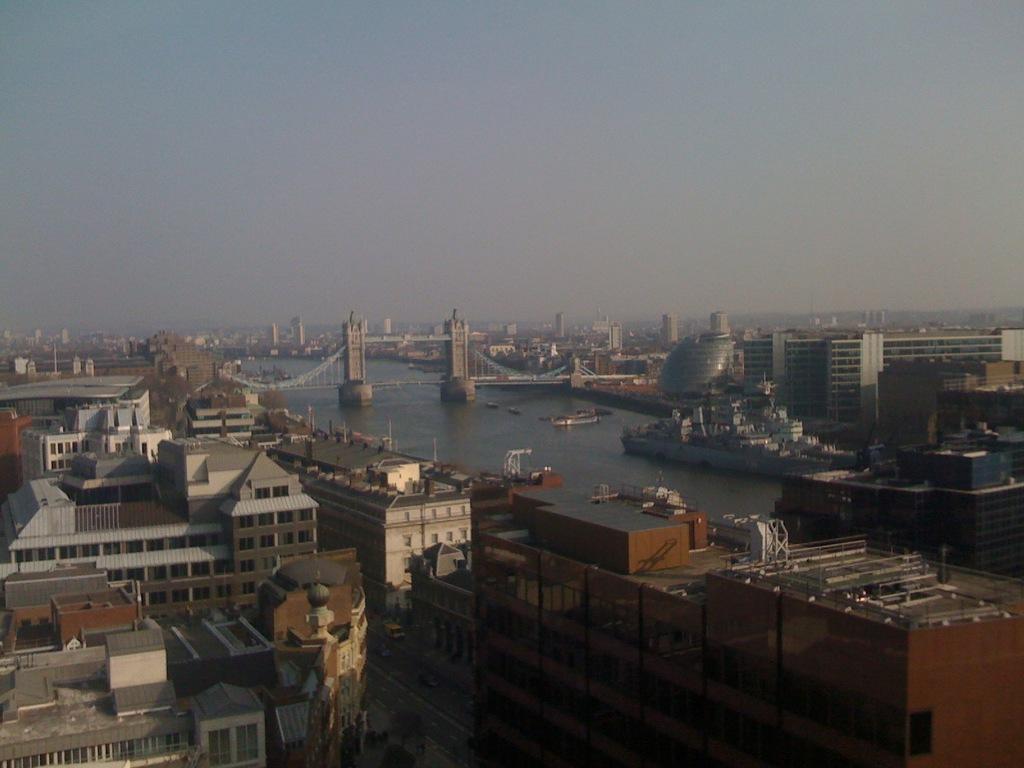Describe this image in one or two sentences. On the left side there are many buildings with windows. Near to that there is a river. On that there is a ship. In the back there is a bridge. In the background there are many buildings and sky. 